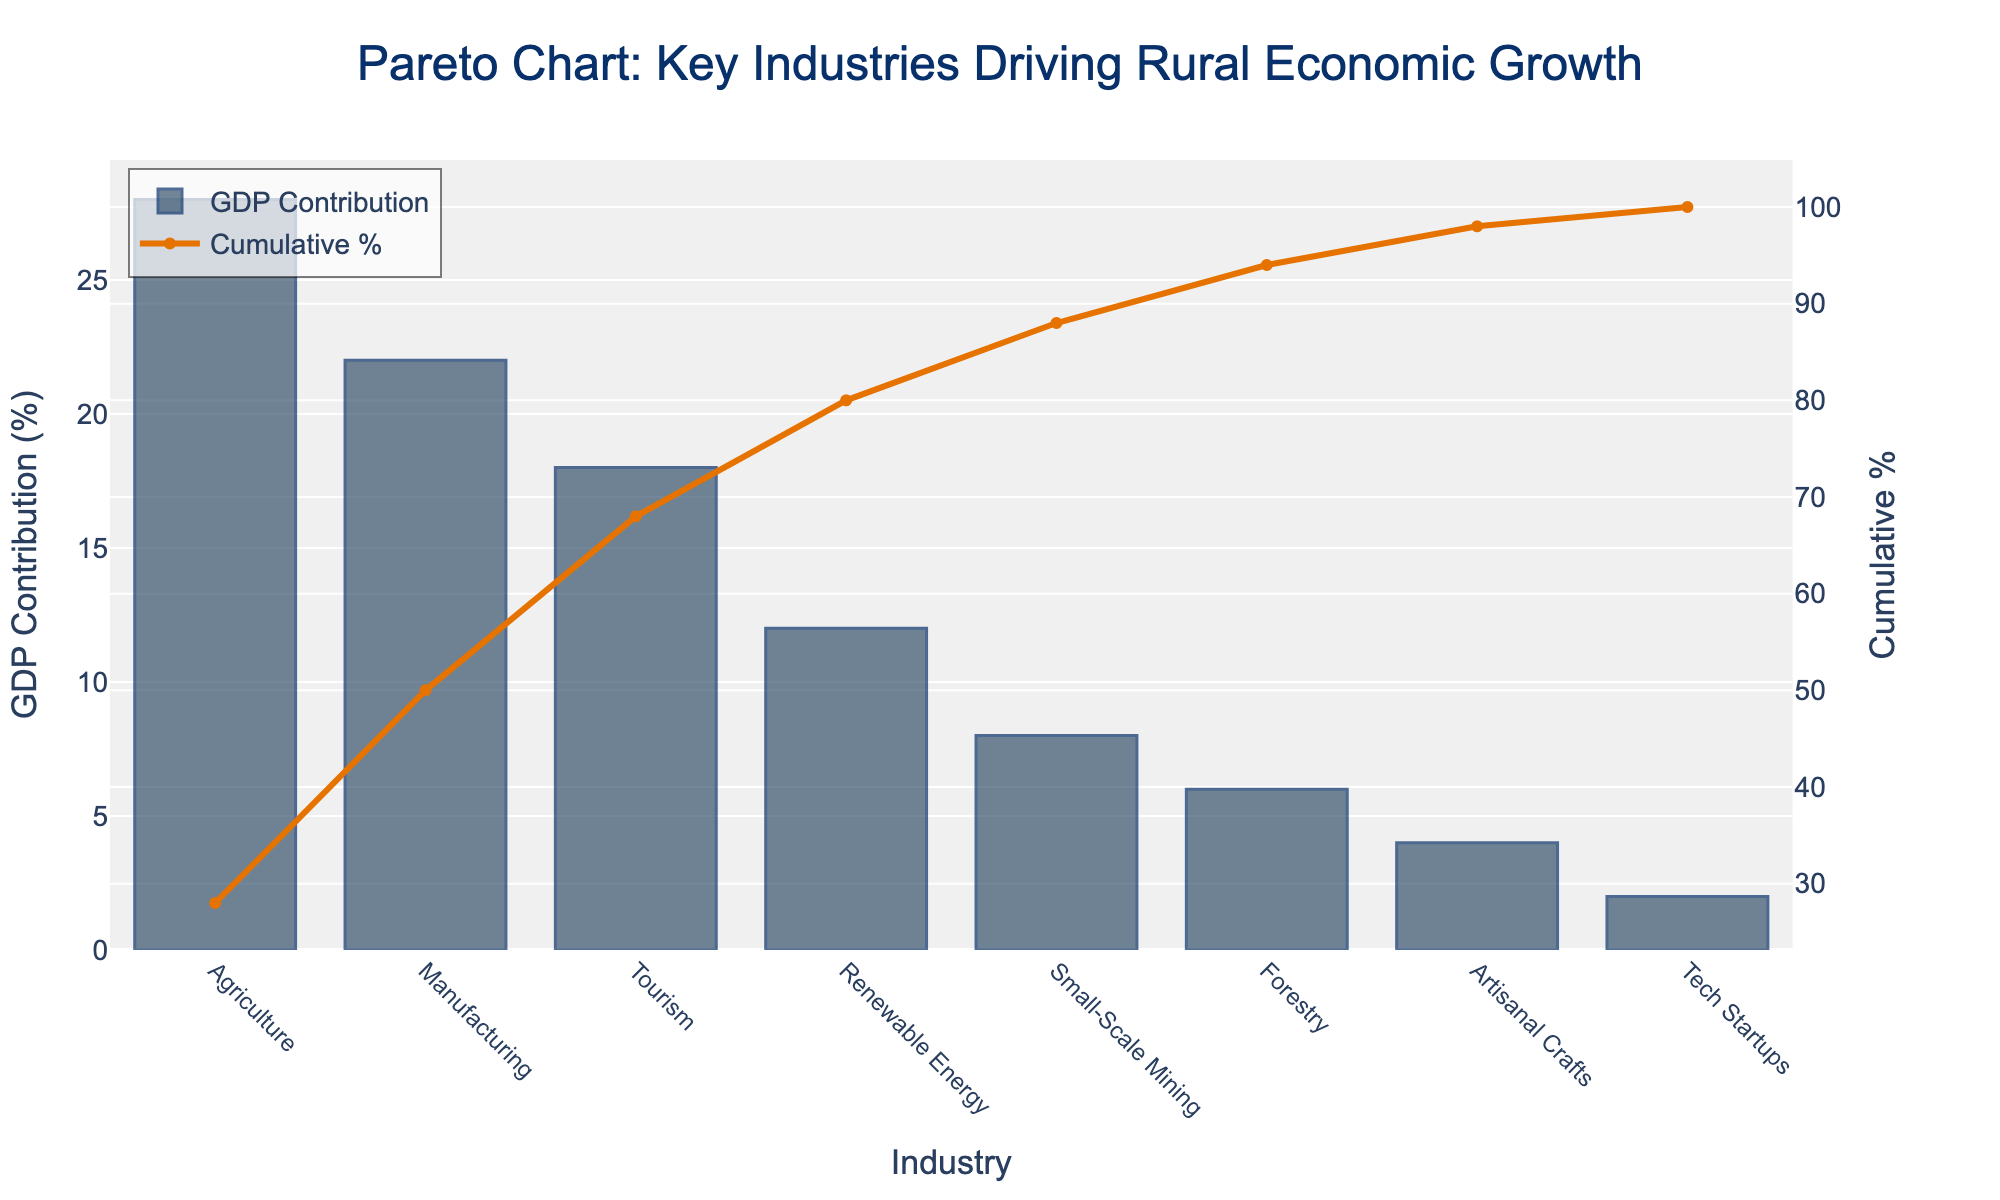What is the title of the chart? The title is typically located at the top center of the chart. It reads "Pareto Chart: Key Industries Driving Rural Economic Growth."
Answer: Pareto Chart: Key Industries Driving Rural Economic Growth Which industry contributes the most to local GDP? The bar representing "Agriculture" is the tallest, indicating it has the highest GDP contribution percentage.
Answer: Agriculture What color are the bars representing GDP contribution? The bars are primarily colored in shades of blue.
Answer: Blue What is the GDP contribution of Manufacturing? The height of the bar labeled "Manufacturing" indicates a GDP contribution percentage of 22%.
Answer: 22% How many industries are shown in the chart? By counting the bars on the x-axis, we see there are eight different industries represented.
Answer: 8 What percentage of the GDP is contributed cumulatively by the top three industries? The top three industries are Agriculture, Manufacturing, and Tourism, with contributions of 28%, 22%, and 18%, respectively. Their cumulative contribution is 28% + 22% + 18% = 68%.
Answer: 68% Is the cumulative percentage curve continuously increasing? The cumulative line graph consistently moves upward from left to right, indicating continuous accumulation.
Answer: Yes How does the GDP contribution of Tech Startups compare to Artisanal Crafts? The bar for Tech Startups is shorter than the bar for Artisanal Crafts. Tech Startups have a GDP contribution of 2%, while Artisanal Crafts contribute 4%.
Answer: Less What is the cumulative percentage after including Small-Scale Mining? The cumulative percentages are shown on the secondary y-axis. Up to Small-Scale Mining, the cumulative contribution is recorded as 28% (Agriculture) + 22% (Manufacturing) + 18% (Tourism) + 12% (Renewable Energy) + 8% (Small-Scale Mining) = 88%.
Answer: 88% Which industry shows a cumulative percentage of 90%? From the secondary y-axis, Renewable Energy's cumulative percentage tells us that adding the next industry, Small-Scale Mining and Forestry, contributes to the 90% threshold. This implies that the 90% mark is reached right after Forestry.
Answer: Forestry 